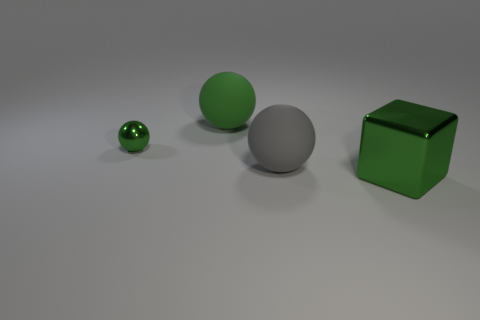Do the big shiny thing and the gray matte object have the same shape?
Provide a short and direct response. No. Is there any other thing that is made of the same material as the big green cube?
Provide a succinct answer. Yes. How many large green things are on the right side of the gray ball and behind the green metallic ball?
Give a very brief answer. 0. What is the color of the big block that is on the right side of the green metallic thing to the left of the green metal cube?
Make the answer very short. Green. Is the number of large matte spheres that are behind the green shiny ball the same as the number of balls?
Provide a succinct answer. No. What number of green cubes are behind the cube that is in front of the large green thing that is behind the big gray sphere?
Your response must be concise. 0. The shiny thing behind the cube is what color?
Give a very brief answer. Green. There is a green thing that is on the right side of the tiny metallic thing and behind the gray rubber object; what material is it?
Keep it short and to the point. Rubber. There is a matte sphere that is behind the small metallic sphere; how many small metal spheres are right of it?
Keep it short and to the point. 0. There is a green matte thing; what shape is it?
Provide a short and direct response. Sphere. 